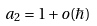<formula> <loc_0><loc_0><loc_500><loc_500>a _ { 2 } = 1 + o ( \hbar { ) }</formula> 